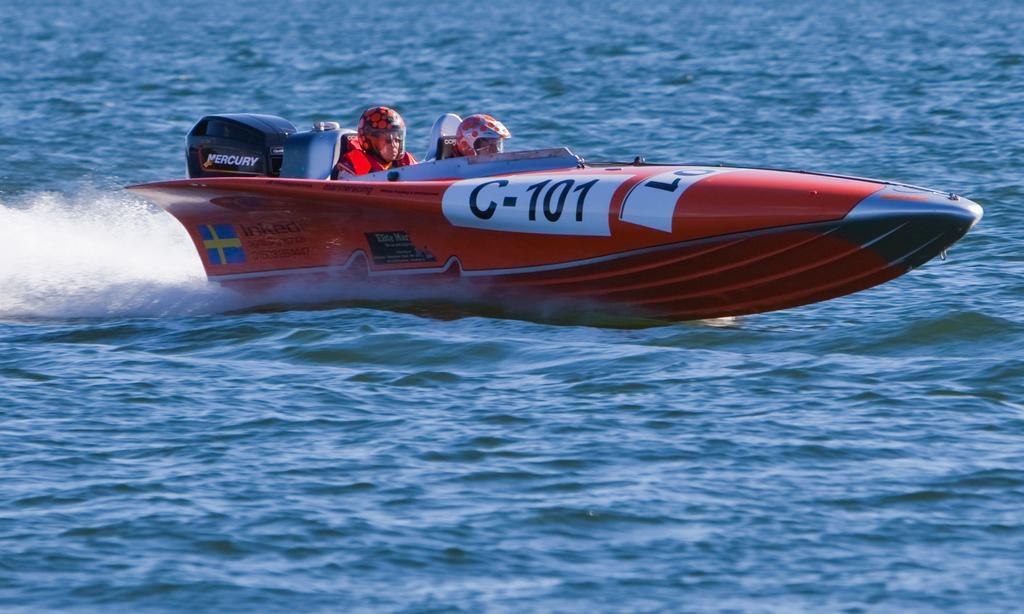How would you summarize this image in a sentence or two? In this picture I can see there are two persons riding a boat and they are wearing life jackets and helmet. I can see there is flow in the water. 